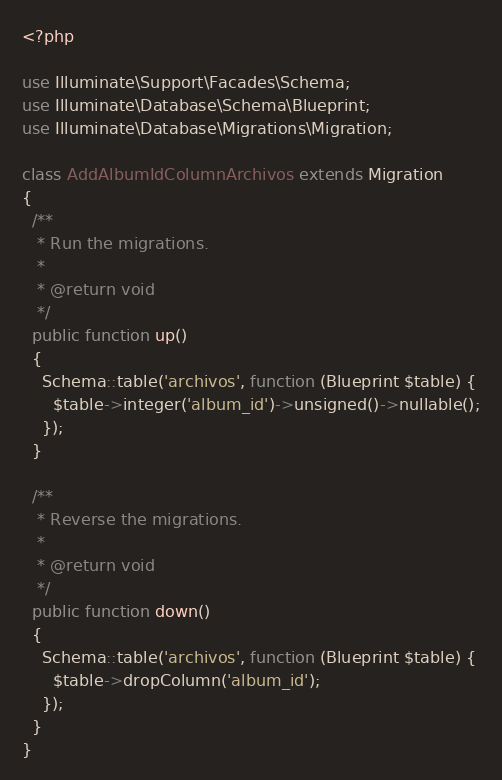<code> <loc_0><loc_0><loc_500><loc_500><_PHP_><?php

use Illuminate\Support\Facades\Schema;
use Illuminate\Database\Schema\Blueprint;
use Illuminate\Database\Migrations\Migration;

class AddAlbumIdColumnArchivos extends Migration
{
  /**
   * Run the migrations.
   *
   * @return void
   */
  public function up()
  {
    Schema::table('archivos', function (Blueprint $table) {
      $table->integer('album_id')->unsigned()->nullable();
    });
  }

  /**
   * Reverse the migrations.
   *
   * @return void
   */
  public function down()
  {
    Schema::table('archivos', function (Blueprint $table) {
      $table->dropColumn('album_id');
    });
  }
}
</code> 